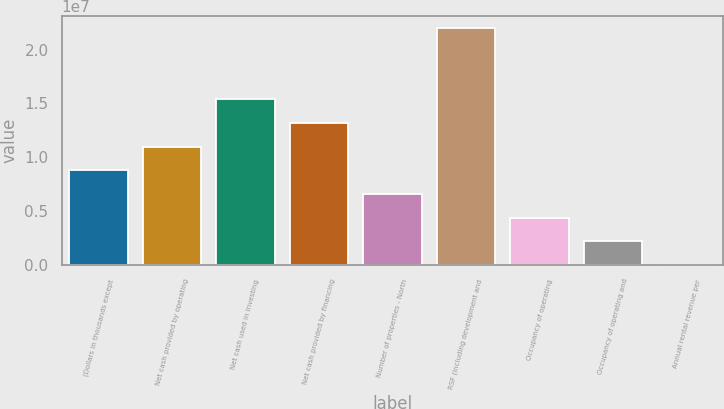Convert chart. <chart><loc_0><loc_0><loc_500><loc_500><bar_chart><fcel>(Dollars in thousands except<fcel>Net cash provided by operating<fcel>Net cash used in investing<fcel>Net cash provided by financing<fcel>Number of properties - North<fcel>RSF (including development and<fcel>Occupancy of operating<fcel>Occupancy of operating and<fcel>Annual rental revenue per<nl><fcel>8.79248e+06<fcel>1.09906e+07<fcel>1.53868e+07<fcel>1.31887e+07<fcel>6.59437e+06<fcel>2.19811e+07<fcel>4.39627e+06<fcel>2.19816e+06<fcel>48.01<nl></chart> 